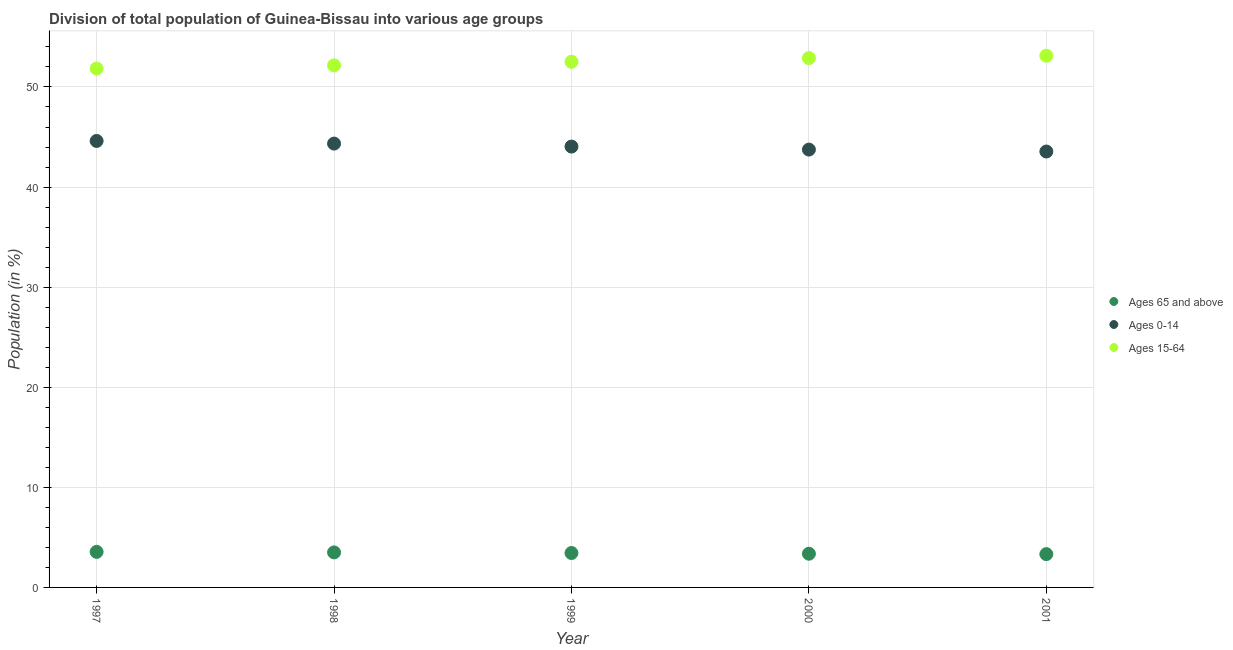How many different coloured dotlines are there?
Your answer should be compact. 3. Is the number of dotlines equal to the number of legend labels?
Ensure brevity in your answer.  Yes. What is the percentage of population within the age-group 0-14 in 1997?
Provide a succinct answer. 44.61. Across all years, what is the maximum percentage of population within the age-group 0-14?
Offer a very short reply. 44.61. Across all years, what is the minimum percentage of population within the age-group 0-14?
Your answer should be very brief. 43.55. In which year was the percentage of population within the age-group of 65 and above maximum?
Ensure brevity in your answer.  1997. What is the total percentage of population within the age-group 15-64 in the graph?
Give a very brief answer. 262.52. What is the difference between the percentage of population within the age-group 0-14 in 1998 and that in 2001?
Offer a terse response. 0.79. What is the difference between the percentage of population within the age-group 15-64 in 1998 and the percentage of population within the age-group 0-14 in 2000?
Offer a very short reply. 8.41. What is the average percentage of population within the age-group 0-14 per year?
Offer a very short reply. 44.06. In the year 1999, what is the difference between the percentage of population within the age-group 0-14 and percentage of population within the age-group 15-64?
Keep it short and to the point. -8.47. What is the ratio of the percentage of population within the age-group of 65 and above in 1999 to that in 2001?
Provide a succinct answer. 1.03. Is the difference between the percentage of population within the age-group of 65 and above in 1997 and 1998 greater than the difference between the percentage of population within the age-group 15-64 in 1997 and 1998?
Ensure brevity in your answer.  Yes. What is the difference between the highest and the second highest percentage of population within the age-group of 65 and above?
Offer a terse response. 0.05. What is the difference between the highest and the lowest percentage of population within the age-group of 65 and above?
Provide a succinct answer. 0.22. In how many years, is the percentage of population within the age-group of 65 and above greater than the average percentage of population within the age-group of 65 and above taken over all years?
Your answer should be compact. 3. Is the percentage of population within the age-group of 65 and above strictly greater than the percentage of population within the age-group 0-14 over the years?
Make the answer very short. No. Is the percentage of population within the age-group 15-64 strictly less than the percentage of population within the age-group of 65 and above over the years?
Offer a very short reply. No. How many dotlines are there?
Your answer should be compact. 3. How many years are there in the graph?
Your response must be concise. 5. Does the graph contain any zero values?
Your response must be concise. No. How many legend labels are there?
Give a very brief answer. 3. How are the legend labels stacked?
Your response must be concise. Vertical. What is the title of the graph?
Provide a succinct answer. Division of total population of Guinea-Bissau into various age groups
. Does "Refusal of sex" appear as one of the legend labels in the graph?
Provide a short and direct response. No. What is the label or title of the Y-axis?
Your answer should be compact. Population (in %). What is the Population (in %) of Ages 65 and above in 1997?
Make the answer very short. 3.55. What is the Population (in %) in Ages 0-14 in 1997?
Offer a very short reply. 44.61. What is the Population (in %) of Ages 15-64 in 1997?
Give a very brief answer. 51.84. What is the Population (in %) of Ages 65 and above in 1998?
Offer a very short reply. 3.5. What is the Population (in %) in Ages 0-14 in 1998?
Make the answer very short. 44.34. What is the Population (in %) in Ages 15-64 in 1998?
Your answer should be very brief. 52.16. What is the Population (in %) of Ages 65 and above in 1999?
Your answer should be compact. 3.44. What is the Population (in %) in Ages 0-14 in 1999?
Ensure brevity in your answer.  44.05. What is the Population (in %) of Ages 15-64 in 1999?
Keep it short and to the point. 52.52. What is the Population (in %) of Ages 65 and above in 2000?
Your answer should be very brief. 3.37. What is the Population (in %) of Ages 0-14 in 2000?
Offer a very short reply. 43.74. What is the Population (in %) in Ages 15-64 in 2000?
Give a very brief answer. 52.89. What is the Population (in %) in Ages 65 and above in 2001?
Keep it short and to the point. 3.33. What is the Population (in %) of Ages 0-14 in 2001?
Provide a succinct answer. 43.55. What is the Population (in %) of Ages 15-64 in 2001?
Provide a short and direct response. 53.12. Across all years, what is the maximum Population (in %) of Ages 65 and above?
Keep it short and to the point. 3.55. Across all years, what is the maximum Population (in %) in Ages 0-14?
Provide a short and direct response. 44.61. Across all years, what is the maximum Population (in %) in Ages 15-64?
Your response must be concise. 53.12. Across all years, what is the minimum Population (in %) of Ages 65 and above?
Provide a short and direct response. 3.33. Across all years, what is the minimum Population (in %) in Ages 0-14?
Offer a terse response. 43.55. Across all years, what is the minimum Population (in %) of Ages 15-64?
Provide a short and direct response. 51.84. What is the total Population (in %) in Ages 65 and above in the graph?
Your response must be concise. 17.18. What is the total Population (in %) in Ages 0-14 in the graph?
Provide a succinct answer. 220.3. What is the total Population (in %) in Ages 15-64 in the graph?
Your answer should be compact. 262.52. What is the difference between the Population (in %) of Ages 65 and above in 1997 and that in 1998?
Provide a short and direct response. 0.05. What is the difference between the Population (in %) of Ages 0-14 in 1997 and that in 1998?
Your response must be concise. 0.26. What is the difference between the Population (in %) in Ages 15-64 in 1997 and that in 1998?
Keep it short and to the point. -0.32. What is the difference between the Population (in %) of Ages 65 and above in 1997 and that in 1999?
Ensure brevity in your answer.  0.11. What is the difference between the Population (in %) in Ages 0-14 in 1997 and that in 1999?
Your response must be concise. 0.56. What is the difference between the Population (in %) in Ages 15-64 in 1997 and that in 1999?
Provide a short and direct response. -0.68. What is the difference between the Population (in %) in Ages 65 and above in 1997 and that in 2000?
Give a very brief answer. 0.18. What is the difference between the Population (in %) of Ages 0-14 in 1997 and that in 2000?
Offer a very short reply. 0.86. What is the difference between the Population (in %) of Ages 15-64 in 1997 and that in 2000?
Ensure brevity in your answer.  -1.05. What is the difference between the Population (in %) in Ages 65 and above in 1997 and that in 2001?
Provide a short and direct response. 0.22. What is the difference between the Population (in %) of Ages 0-14 in 1997 and that in 2001?
Your answer should be very brief. 1.06. What is the difference between the Population (in %) of Ages 15-64 in 1997 and that in 2001?
Give a very brief answer. -1.28. What is the difference between the Population (in %) of Ages 65 and above in 1998 and that in 1999?
Ensure brevity in your answer.  0.06. What is the difference between the Population (in %) in Ages 0-14 in 1998 and that in 1999?
Make the answer very short. 0.3. What is the difference between the Population (in %) in Ages 15-64 in 1998 and that in 1999?
Offer a terse response. -0.36. What is the difference between the Population (in %) in Ages 65 and above in 1998 and that in 2000?
Provide a succinct answer. 0.13. What is the difference between the Population (in %) in Ages 0-14 in 1998 and that in 2000?
Offer a terse response. 0.6. What is the difference between the Population (in %) of Ages 15-64 in 1998 and that in 2000?
Offer a terse response. -0.73. What is the difference between the Population (in %) in Ages 65 and above in 1998 and that in 2001?
Make the answer very short. 0.17. What is the difference between the Population (in %) of Ages 0-14 in 1998 and that in 2001?
Keep it short and to the point. 0.79. What is the difference between the Population (in %) in Ages 15-64 in 1998 and that in 2001?
Your answer should be compact. -0.96. What is the difference between the Population (in %) in Ages 65 and above in 1999 and that in 2000?
Offer a terse response. 0.07. What is the difference between the Population (in %) of Ages 0-14 in 1999 and that in 2000?
Offer a terse response. 0.3. What is the difference between the Population (in %) in Ages 15-64 in 1999 and that in 2000?
Your response must be concise. -0.37. What is the difference between the Population (in %) in Ages 65 and above in 1999 and that in 2001?
Ensure brevity in your answer.  0.11. What is the difference between the Population (in %) in Ages 0-14 in 1999 and that in 2001?
Your answer should be compact. 0.49. What is the difference between the Population (in %) in Ages 15-64 in 1999 and that in 2001?
Make the answer very short. -0.6. What is the difference between the Population (in %) of Ages 65 and above in 2000 and that in 2001?
Provide a short and direct response. 0.04. What is the difference between the Population (in %) of Ages 0-14 in 2000 and that in 2001?
Your answer should be compact. 0.19. What is the difference between the Population (in %) of Ages 15-64 in 2000 and that in 2001?
Offer a terse response. -0.23. What is the difference between the Population (in %) in Ages 65 and above in 1997 and the Population (in %) in Ages 0-14 in 1998?
Ensure brevity in your answer.  -40.79. What is the difference between the Population (in %) of Ages 65 and above in 1997 and the Population (in %) of Ages 15-64 in 1998?
Keep it short and to the point. -48.6. What is the difference between the Population (in %) in Ages 0-14 in 1997 and the Population (in %) in Ages 15-64 in 1998?
Your answer should be compact. -7.55. What is the difference between the Population (in %) of Ages 65 and above in 1997 and the Population (in %) of Ages 0-14 in 1999?
Make the answer very short. -40.49. What is the difference between the Population (in %) of Ages 65 and above in 1997 and the Population (in %) of Ages 15-64 in 1999?
Provide a short and direct response. -48.96. What is the difference between the Population (in %) in Ages 0-14 in 1997 and the Population (in %) in Ages 15-64 in 1999?
Ensure brevity in your answer.  -7.91. What is the difference between the Population (in %) of Ages 65 and above in 1997 and the Population (in %) of Ages 0-14 in 2000?
Your answer should be compact. -40.19. What is the difference between the Population (in %) in Ages 65 and above in 1997 and the Population (in %) in Ages 15-64 in 2000?
Provide a short and direct response. -49.34. What is the difference between the Population (in %) in Ages 0-14 in 1997 and the Population (in %) in Ages 15-64 in 2000?
Offer a very short reply. -8.28. What is the difference between the Population (in %) of Ages 65 and above in 1997 and the Population (in %) of Ages 0-14 in 2001?
Provide a succinct answer. -40. What is the difference between the Population (in %) of Ages 65 and above in 1997 and the Population (in %) of Ages 15-64 in 2001?
Ensure brevity in your answer.  -49.57. What is the difference between the Population (in %) of Ages 0-14 in 1997 and the Population (in %) of Ages 15-64 in 2001?
Offer a terse response. -8.51. What is the difference between the Population (in %) of Ages 65 and above in 1998 and the Population (in %) of Ages 0-14 in 1999?
Keep it short and to the point. -40.55. What is the difference between the Population (in %) of Ages 65 and above in 1998 and the Population (in %) of Ages 15-64 in 1999?
Make the answer very short. -49.02. What is the difference between the Population (in %) in Ages 0-14 in 1998 and the Population (in %) in Ages 15-64 in 1999?
Provide a succinct answer. -8.17. What is the difference between the Population (in %) of Ages 65 and above in 1998 and the Population (in %) of Ages 0-14 in 2000?
Offer a very short reply. -40.25. What is the difference between the Population (in %) in Ages 65 and above in 1998 and the Population (in %) in Ages 15-64 in 2000?
Keep it short and to the point. -49.39. What is the difference between the Population (in %) of Ages 0-14 in 1998 and the Population (in %) of Ages 15-64 in 2000?
Offer a very short reply. -8.54. What is the difference between the Population (in %) of Ages 65 and above in 1998 and the Population (in %) of Ages 0-14 in 2001?
Offer a very short reply. -40.05. What is the difference between the Population (in %) of Ages 65 and above in 1998 and the Population (in %) of Ages 15-64 in 2001?
Your response must be concise. -49.62. What is the difference between the Population (in %) of Ages 0-14 in 1998 and the Population (in %) of Ages 15-64 in 2001?
Offer a terse response. -8.78. What is the difference between the Population (in %) of Ages 65 and above in 1999 and the Population (in %) of Ages 0-14 in 2000?
Give a very brief answer. -40.31. What is the difference between the Population (in %) in Ages 65 and above in 1999 and the Population (in %) in Ages 15-64 in 2000?
Offer a very short reply. -49.45. What is the difference between the Population (in %) in Ages 0-14 in 1999 and the Population (in %) in Ages 15-64 in 2000?
Your response must be concise. -8.84. What is the difference between the Population (in %) in Ages 65 and above in 1999 and the Population (in %) in Ages 0-14 in 2001?
Offer a terse response. -40.11. What is the difference between the Population (in %) in Ages 65 and above in 1999 and the Population (in %) in Ages 15-64 in 2001?
Provide a succinct answer. -49.68. What is the difference between the Population (in %) of Ages 0-14 in 1999 and the Population (in %) of Ages 15-64 in 2001?
Offer a very short reply. -9.07. What is the difference between the Population (in %) in Ages 65 and above in 2000 and the Population (in %) in Ages 0-14 in 2001?
Keep it short and to the point. -40.18. What is the difference between the Population (in %) in Ages 65 and above in 2000 and the Population (in %) in Ages 15-64 in 2001?
Offer a terse response. -49.75. What is the difference between the Population (in %) in Ages 0-14 in 2000 and the Population (in %) in Ages 15-64 in 2001?
Make the answer very short. -9.38. What is the average Population (in %) of Ages 65 and above per year?
Offer a terse response. 3.44. What is the average Population (in %) of Ages 0-14 per year?
Provide a short and direct response. 44.06. What is the average Population (in %) in Ages 15-64 per year?
Offer a very short reply. 52.5. In the year 1997, what is the difference between the Population (in %) of Ages 65 and above and Population (in %) of Ages 0-14?
Provide a succinct answer. -41.06. In the year 1997, what is the difference between the Population (in %) of Ages 65 and above and Population (in %) of Ages 15-64?
Provide a succinct answer. -48.29. In the year 1997, what is the difference between the Population (in %) in Ages 0-14 and Population (in %) in Ages 15-64?
Offer a very short reply. -7.23. In the year 1998, what is the difference between the Population (in %) in Ages 65 and above and Population (in %) in Ages 0-14?
Your response must be concise. -40.85. In the year 1998, what is the difference between the Population (in %) in Ages 65 and above and Population (in %) in Ages 15-64?
Offer a very short reply. -48.66. In the year 1998, what is the difference between the Population (in %) in Ages 0-14 and Population (in %) in Ages 15-64?
Make the answer very short. -7.81. In the year 1999, what is the difference between the Population (in %) of Ages 65 and above and Population (in %) of Ages 0-14?
Give a very brief answer. -40.61. In the year 1999, what is the difference between the Population (in %) of Ages 65 and above and Population (in %) of Ages 15-64?
Your answer should be compact. -49.08. In the year 1999, what is the difference between the Population (in %) in Ages 0-14 and Population (in %) in Ages 15-64?
Provide a short and direct response. -8.47. In the year 2000, what is the difference between the Population (in %) in Ages 65 and above and Population (in %) in Ages 0-14?
Provide a short and direct response. -40.38. In the year 2000, what is the difference between the Population (in %) in Ages 65 and above and Population (in %) in Ages 15-64?
Give a very brief answer. -49.52. In the year 2000, what is the difference between the Population (in %) of Ages 0-14 and Population (in %) of Ages 15-64?
Your answer should be compact. -9.14. In the year 2001, what is the difference between the Population (in %) of Ages 65 and above and Population (in %) of Ages 0-14?
Make the answer very short. -40.22. In the year 2001, what is the difference between the Population (in %) of Ages 65 and above and Population (in %) of Ages 15-64?
Offer a terse response. -49.79. In the year 2001, what is the difference between the Population (in %) in Ages 0-14 and Population (in %) in Ages 15-64?
Give a very brief answer. -9.57. What is the ratio of the Population (in %) in Ages 65 and above in 1997 to that in 1998?
Your answer should be compact. 1.02. What is the ratio of the Population (in %) in Ages 65 and above in 1997 to that in 1999?
Offer a terse response. 1.03. What is the ratio of the Population (in %) of Ages 0-14 in 1997 to that in 1999?
Offer a very short reply. 1.01. What is the ratio of the Population (in %) of Ages 15-64 in 1997 to that in 1999?
Make the answer very short. 0.99. What is the ratio of the Population (in %) in Ages 65 and above in 1997 to that in 2000?
Provide a succinct answer. 1.05. What is the ratio of the Population (in %) in Ages 0-14 in 1997 to that in 2000?
Offer a very short reply. 1.02. What is the ratio of the Population (in %) of Ages 15-64 in 1997 to that in 2000?
Provide a succinct answer. 0.98. What is the ratio of the Population (in %) in Ages 65 and above in 1997 to that in 2001?
Your response must be concise. 1.07. What is the ratio of the Population (in %) in Ages 0-14 in 1997 to that in 2001?
Offer a terse response. 1.02. What is the ratio of the Population (in %) of Ages 15-64 in 1997 to that in 2001?
Keep it short and to the point. 0.98. What is the ratio of the Population (in %) in Ages 0-14 in 1998 to that in 1999?
Give a very brief answer. 1.01. What is the ratio of the Population (in %) in Ages 15-64 in 1998 to that in 1999?
Provide a short and direct response. 0.99. What is the ratio of the Population (in %) in Ages 65 and above in 1998 to that in 2000?
Give a very brief answer. 1.04. What is the ratio of the Population (in %) in Ages 0-14 in 1998 to that in 2000?
Offer a terse response. 1.01. What is the ratio of the Population (in %) in Ages 15-64 in 1998 to that in 2000?
Your answer should be compact. 0.99. What is the ratio of the Population (in %) in Ages 65 and above in 1998 to that in 2001?
Make the answer very short. 1.05. What is the ratio of the Population (in %) in Ages 0-14 in 1998 to that in 2001?
Offer a terse response. 1.02. What is the ratio of the Population (in %) in Ages 15-64 in 1998 to that in 2001?
Keep it short and to the point. 0.98. What is the ratio of the Population (in %) of Ages 65 and above in 1999 to that in 2000?
Your answer should be very brief. 1.02. What is the ratio of the Population (in %) of Ages 15-64 in 1999 to that in 2000?
Your response must be concise. 0.99. What is the ratio of the Population (in %) in Ages 65 and above in 1999 to that in 2001?
Your answer should be compact. 1.03. What is the ratio of the Population (in %) of Ages 0-14 in 1999 to that in 2001?
Offer a very short reply. 1.01. What is the ratio of the Population (in %) of Ages 15-64 in 1999 to that in 2001?
Ensure brevity in your answer.  0.99. What is the ratio of the Population (in %) of Ages 65 and above in 2000 to that in 2001?
Provide a short and direct response. 1.01. What is the ratio of the Population (in %) in Ages 15-64 in 2000 to that in 2001?
Offer a terse response. 1. What is the difference between the highest and the second highest Population (in %) of Ages 65 and above?
Your answer should be very brief. 0.05. What is the difference between the highest and the second highest Population (in %) of Ages 0-14?
Provide a short and direct response. 0.26. What is the difference between the highest and the second highest Population (in %) in Ages 15-64?
Provide a succinct answer. 0.23. What is the difference between the highest and the lowest Population (in %) of Ages 65 and above?
Your response must be concise. 0.22. What is the difference between the highest and the lowest Population (in %) in Ages 0-14?
Provide a short and direct response. 1.06. What is the difference between the highest and the lowest Population (in %) of Ages 15-64?
Your answer should be very brief. 1.28. 